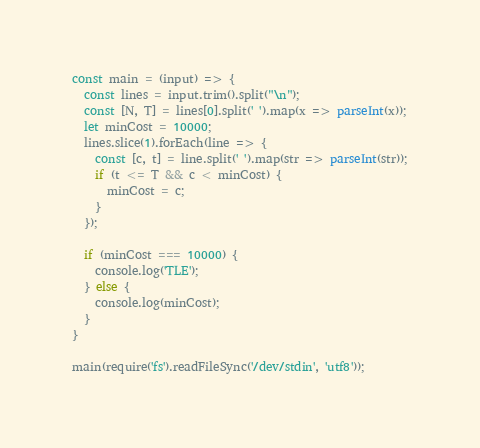<code> <loc_0><loc_0><loc_500><loc_500><_TypeScript_>const main = (input) => {
  const lines = input.trim().split("\n");
  const [N, T] = lines[0].split(' ').map(x => parseInt(x));
  let minCost = 10000;
  lines.slice(1).forEach(line => {
    const [c, t] = line.split(' ').map(str => parseInt(str));
    if (t <= T && c < minCost) {
      minCost = c;
    }
  });

  if (minCost === 10000) {
    console.log('TLE');
  } else {
    console.log(minCost);
  }
}

main(require('fs').readFileSync('/dev/stdin', 'utf8'));

</code> 